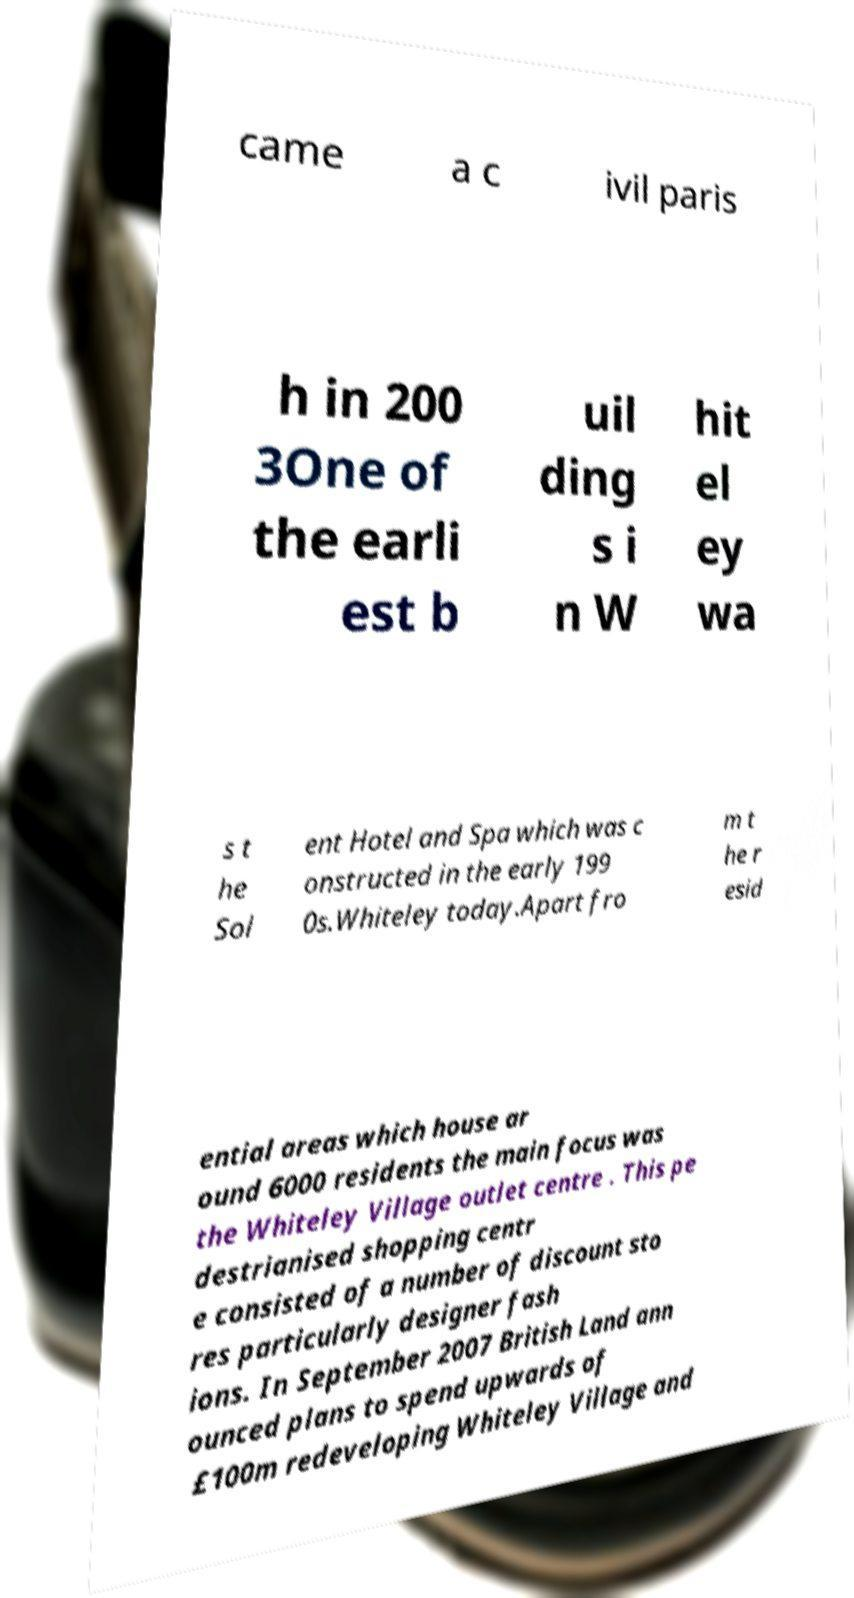Please identify and transcribe the text found in this image. came a c ivil paris h in 200 3One of the earli est b uil ding s i n W hit el ey wa s t he Sol ent Hotel and Spa which was c onstructed in the early 199 0s.Whiteley today.Apart fro m t he r esid ential areas which house ar ound 6000 residents the main focus was the Whiteley Village outlet centre . This pe destrianised shopping centr e consisted of a number of discount sto res particularly designer fash ions. In September 2007 British Land ann ounced plans to spend upwards of £100m redeveloping Whiteley Village and 